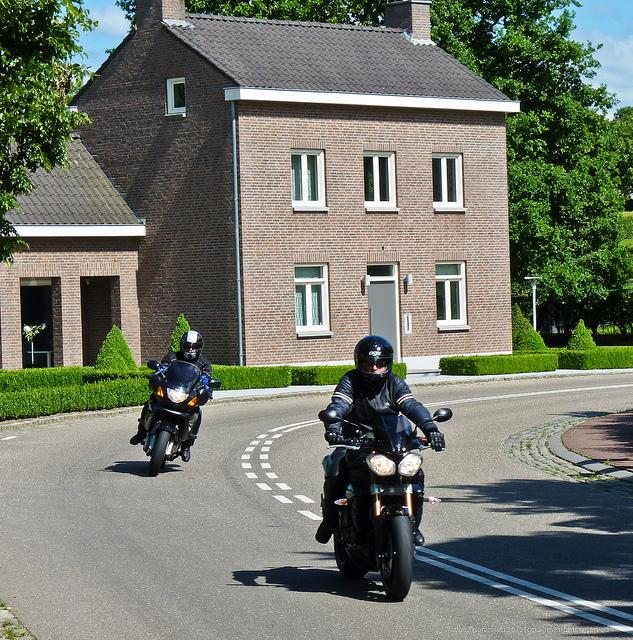What color are the stripes on the sleeves of the jacket worn by the motorcyclist in front?

Choices:
A) blue
B) white
C) green
D) red white 